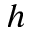<formula> <loc_0><loc_0><loc_500><loc_500>h</formula> 